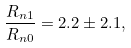<formula> <loc_0><loc_0><loc_500><loc_500>\frac { R _ { n 1 } } { R _ { n 0 } } = 2 . 2 \pm 2 . 1 ,</formula> 